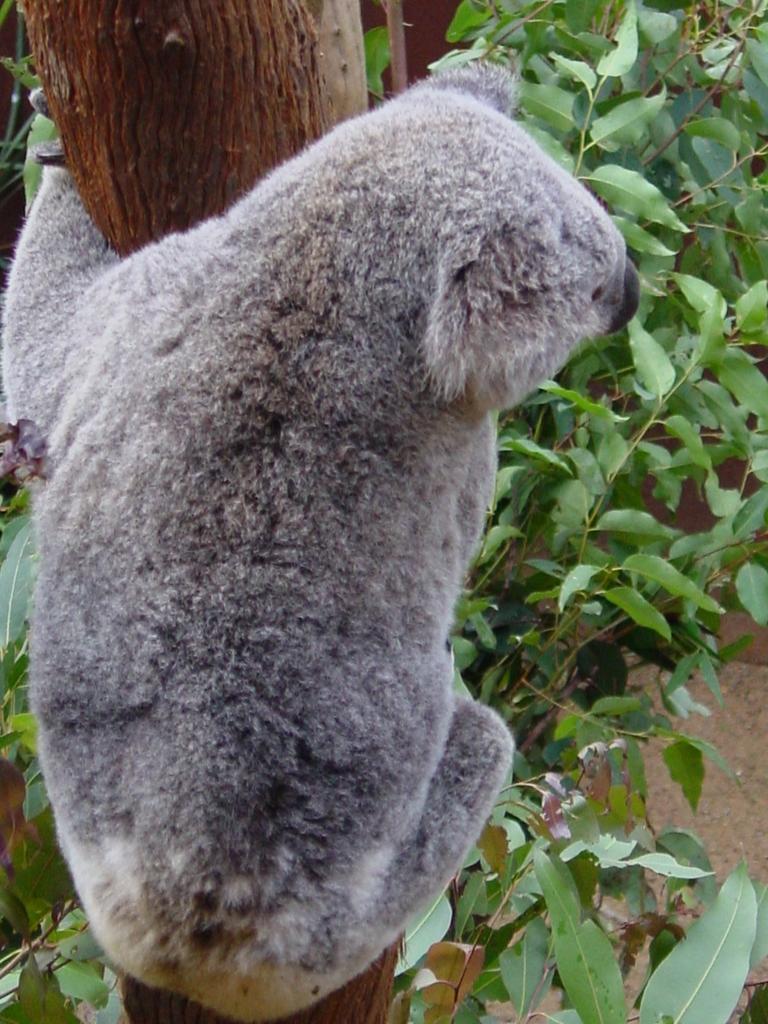How would you summarize this image in a sentence or two? There is a koala on a tree. In the background we can see branches of a tree with leaves. 